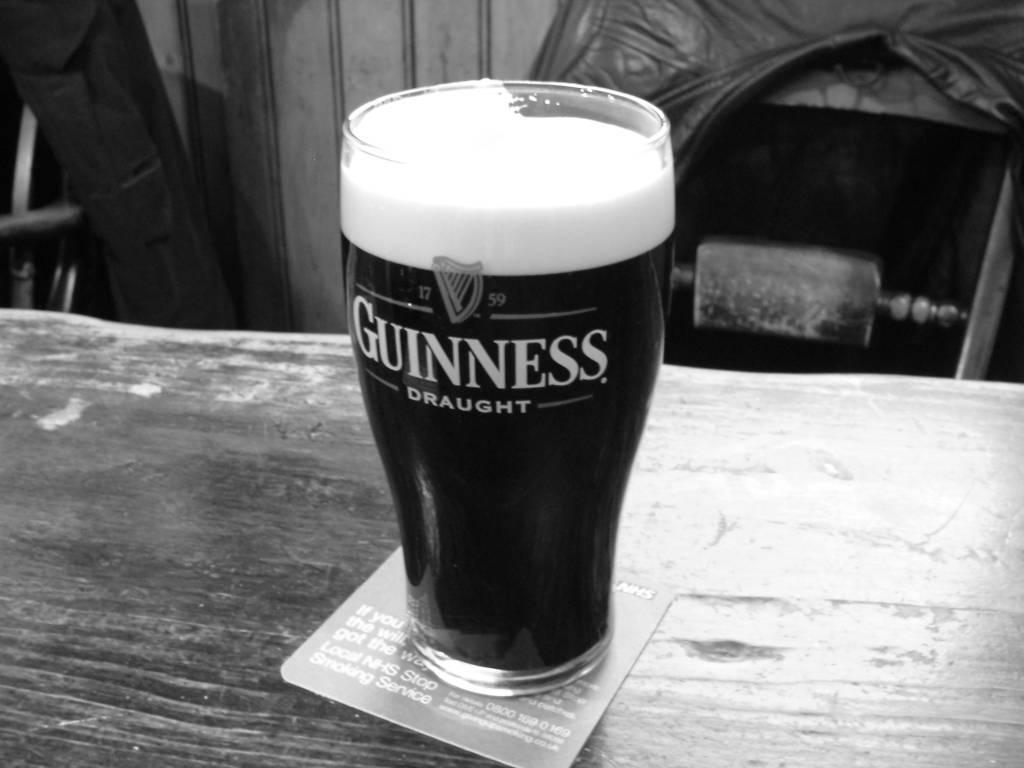What is on the table in the image? There is a card and a glass with liquid on the table. What might be in the glass? The liquid in the glass could be water, juice, or any other beverage. What is located near the table? There are chairs beside the table. What type of button is on the card in the image? There is no button present on the card in the image. Who is the authority figure in the image? There is no authority figure depicted in the image. 